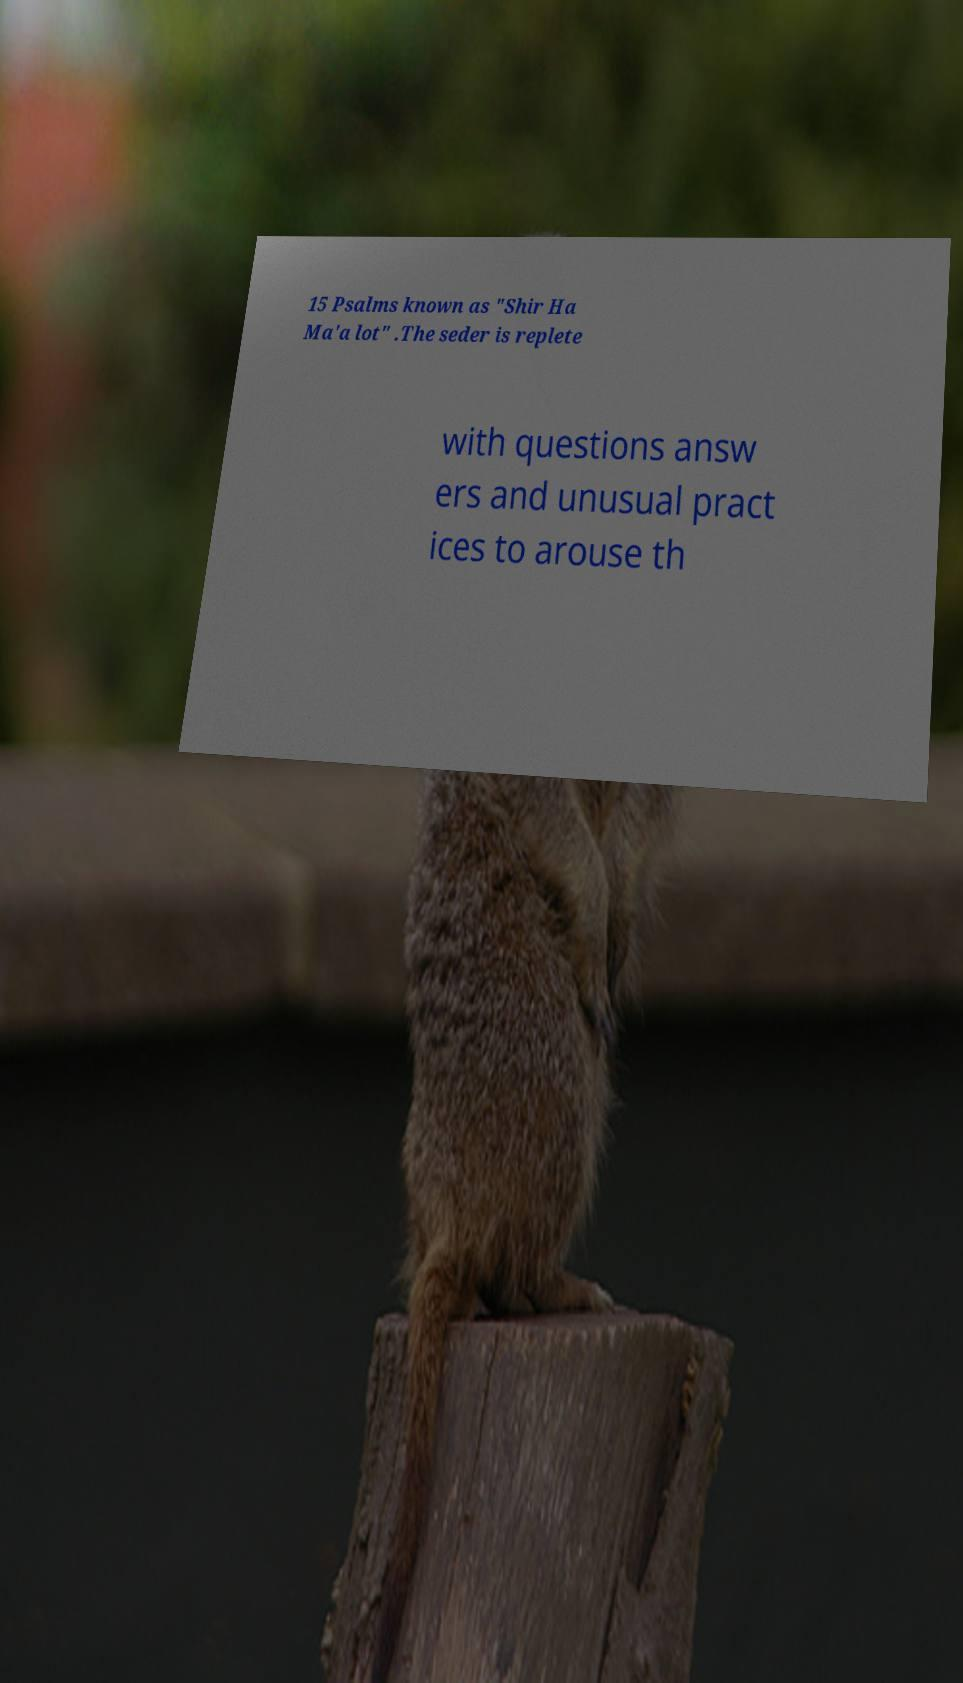Can you read and provide the text displayed in the image?This photo seems to have some interesting text. Can you extract and type it out for me? 15 Psalms known as "Shir Ha Ma'a lot" .The seder is replete with questions answ ers and unusual pract ices to arouse th 